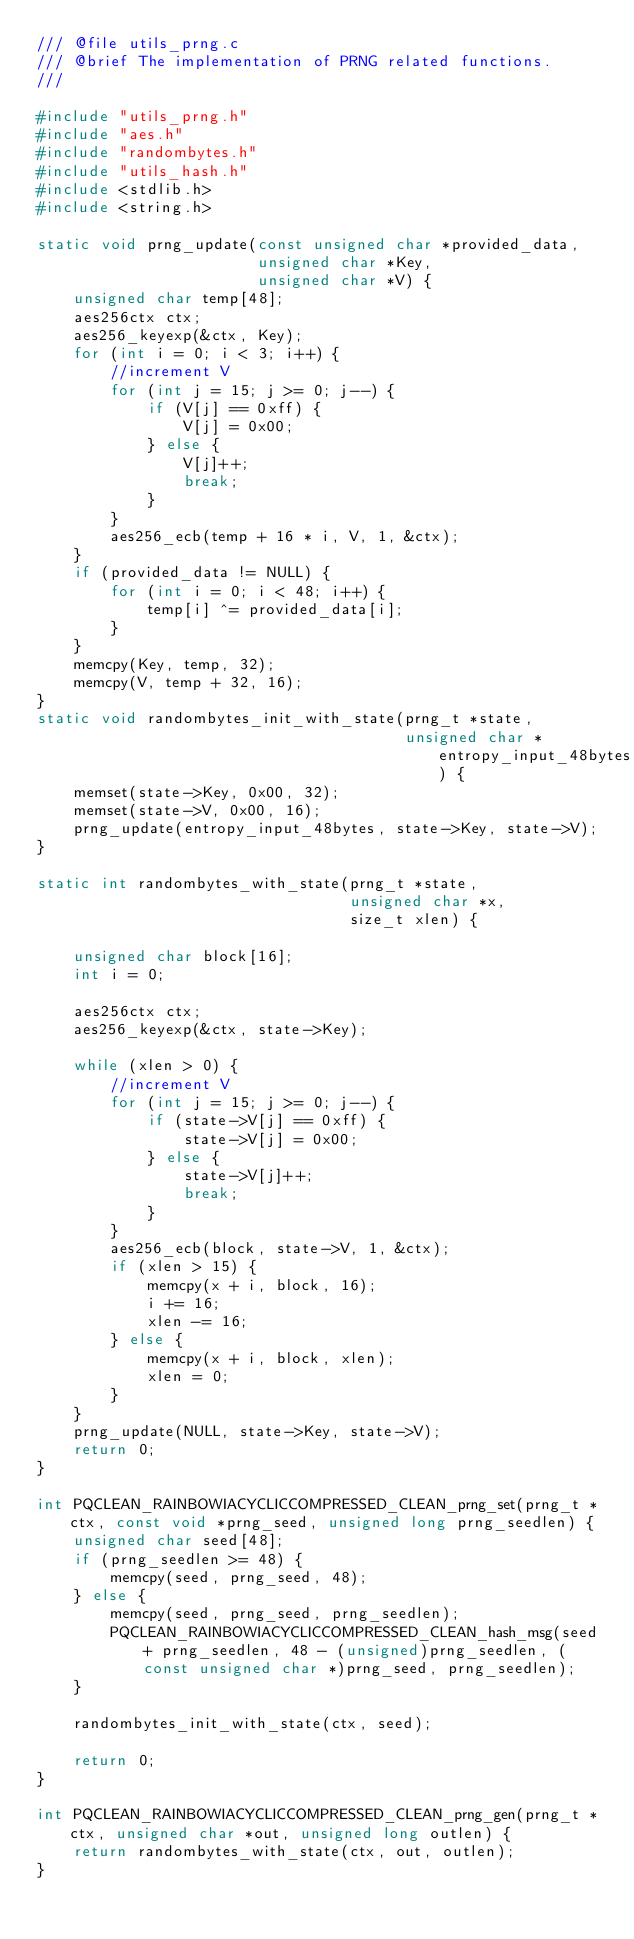<code> <loc_0><loc_0><loc_500><loc_500><_C_>/// @file utils_prng.c
/// @brief The implementation of PRNG related functions.
///

#include "utils_prng.h"
#include "aes.h"
#include "randombytes.h"
#include "utils_hash.h"
#include <stdlib.h>
#include <string.h>

static void prng_update(const unsigned char *provided_data,
                        unsigned char *Key,
                        unsigned char *V) {
    unsigned char temp[48];
    aes256ctx ctx;
    aes256_keyexp(&ctx, Key);
    for (int i = 0; i < 3; i++) {
        //increment V
        for (int j = 15; j >= 0; j--) {
            if (V[j] == 0xff) {
                V[j] = 0x00;
            } else {
                V[j]++;
                break;
            }
        }
        aes256_ecb(temp + 16 * i, V, 1, &ctx);
    }
    if (provided_data != NULL) {
        for (int i = 0; i < 48; i++) {
            temp[i] ^= provided_data[i];
        }
    }
    memcpy(Key, temp, 32);
    memcpy(V, temp + 32, 16);
}
static void randombytes_init_with_state(prng_t *state,
                                        unsigned char *entropy_input_48bytes) {
    memset(state->Key, 0x00, 32);
    memset(state->V, 0x00, 16);
    prng_update(entropy_input_48bytes, state->Key, state->V);
}

static int randombytes_with_state(prng_t *state,
                                  unsigned char *x,
                                  size_t xlen) {

    unsigned char block[16];
    int i = 0;

    aes256ctx ctx;
    aes256_keyexp(&ctx, state->Key);

    while (xlen > 0) {
        //increment V
        for (int j = 15; j >= 0; j--) {
            if (state->V[j] == 0xff) {
                state->V[j] = 0x00;
            } else {
                state->V[j]++;
                break;
            }
        }
        aes256_ecb(block, state->V, 1, &ctx);
        if (xlen > 15) {
            memcpy(x + i, block, 16);
            i += 16;
            xlen -= 16;
        } else {
            memcpy(x + i, block, xlen);
            xlen = 0;
        }
    }
    prng_update(NULL, state->Key, state->V);
    return 0;
}

int PQCLEAN_RAINBOWIACYCLICCOMPRESSED_CLEAN_prng_set(prng_t *ctx, const void *prng_seed, unsigned long prng_seedlen) {
    unsigned char seed[48];
    if (prng_seedlen >= 48) {
        memcpy(seed, prng_seed, 48);
    } else {
        memcpy(seed, prng_seed, prng_seedlen);
        PQCLEAN_RAINBOWIACYCLICCOMPRESSED_CLEAN_hash_msg(seed + prng_seedlen, 48 - (unsigned)prng_seedlen, (const unsigned char *)prng_seed, prng_seedlen);
    }

    randombytes_init_with_state(ctx, seed);

    return 0;
}

int PQCLEAN_RAINBOWIACYCLICCOMPRESSED_CLEAN_prng_gen(prng_t *ctx, unsigned char *out, unsigned long outlen) {
    return randombytes_with_state(ctx, out, outlen);
}
</code> 